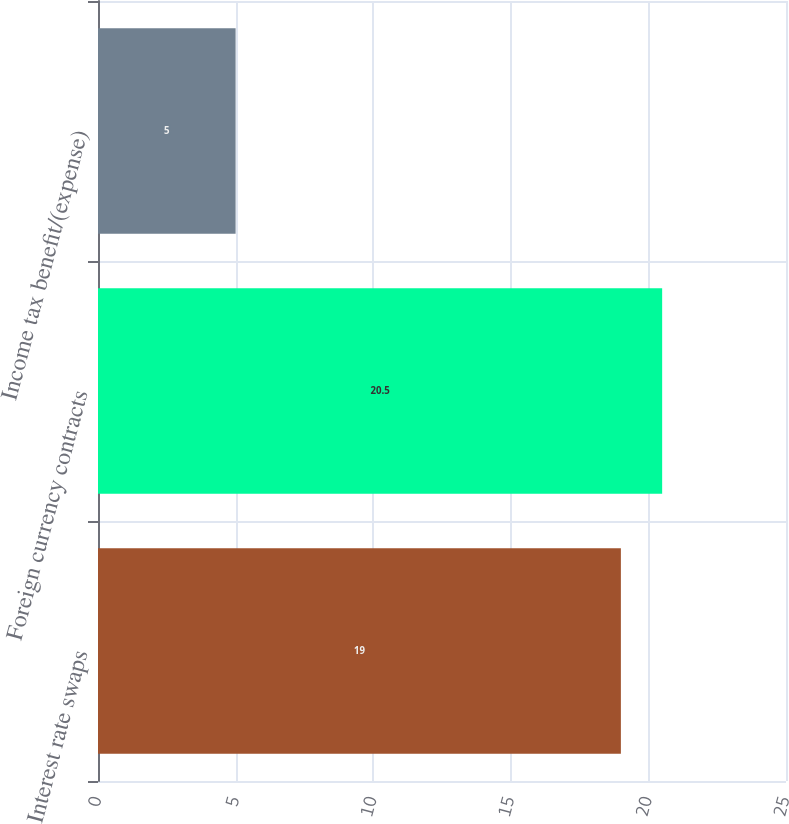Convert chart. <chart><loc_0><loc_0><loc_500><loc_500><bar_chart><fcel>Interest rate swaps<fcel>Foreign currency contracts<fcel>Income tax benefit/(expense)<nl><fcel>19<fcel>20.5<fcel>5<nl></chart> 